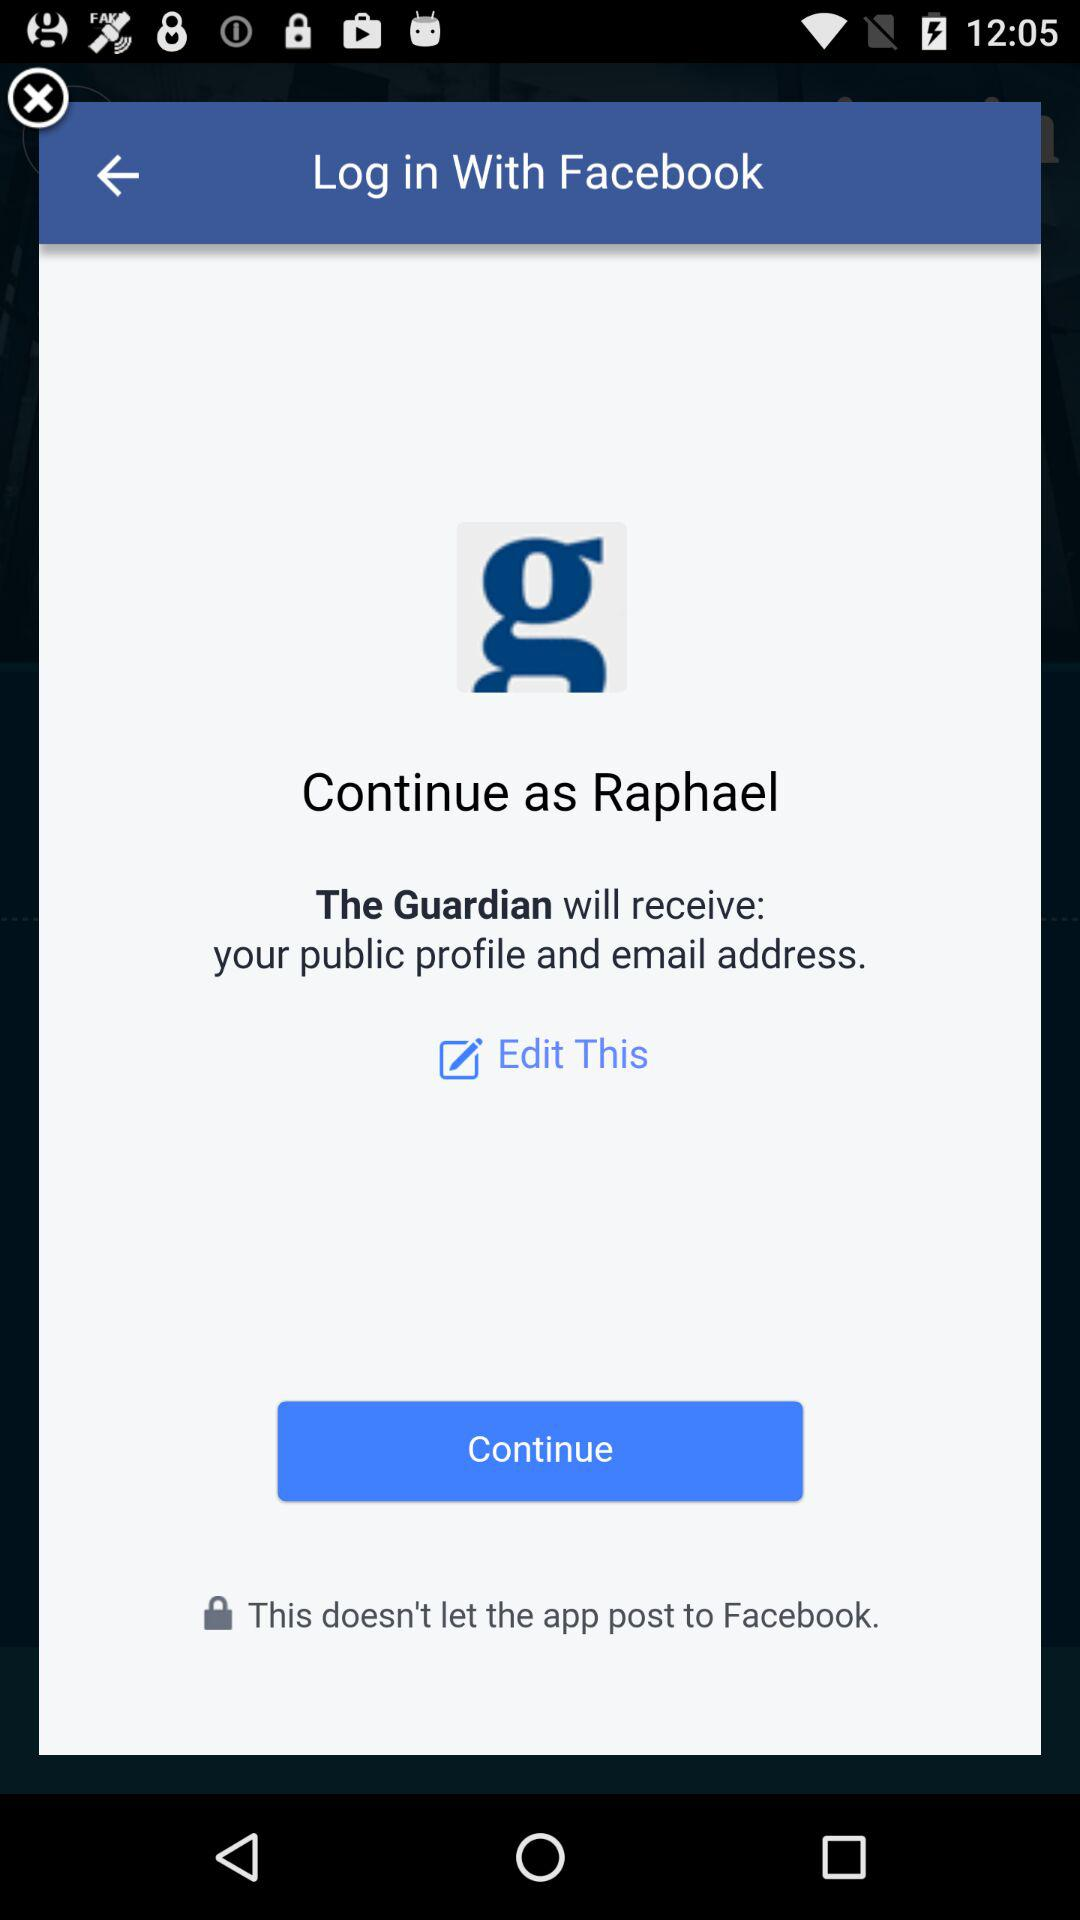Through what application can we log in? You can log in with "Facebook". 